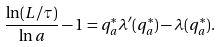<formula> <loc_0><loc_0><loc_500><loc_500>\frac { \ln ( L / \tau ) } { \ln a } - 1 = q ^ { * } _ { a } \lambda ^ { \prime } ( q ^ { * } _ { a } ) - \lambda ( q ^ { * } _ { a } ) .</formula> 